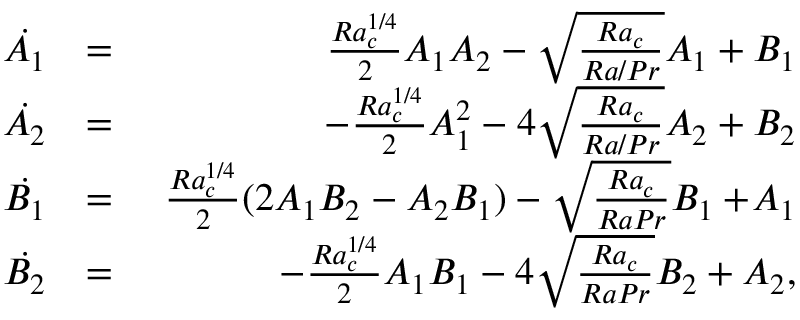<formula> <loc_0><loc_0><loc_500><loc_500>\begin{array} { r l r } { \, \dot { A _ { 1 } } } & { = } & { \ \frac { R a _ { c } ^ { 1 / 4 } } { 2 } A _ { 1 } A _ { 2 } - \sqrt { \frac { R a _ { c } } { R a / P r } } A _ { 1 } + B _ { 1 } } \\ { \, \dot { A _ { 2 } } } & { = } & { - \frac { R a _ { c } ^ { 1 / 4 } } { 2 } A _ { 1 } ^ { 2 } - 4 \sqrt { \frac { R a _ { c } } { R a / P r } } A _ { 2 } + B _ { 2 } } \\ { \, \dot { B _ { 1 } } } & { = } & { \ \frac { R a _ { c } ^ { 1 / 4 } } { 2 } ( 2 A _ { 1 } B _ { 2 } - A _ { 2 } B _ { 1 } ) - \sqrt { \frac { R a _ { c } } { R a P r } } B _ { 1 } + \, A _ { 1 } } \\ { \, \dot { B _ { 2 } } } & { = } & { - \frac { R a _ { c } ^ { 1 / 4 } } { 2 } A _ { 1 } B _ { 1 } - 4 \sqrt { \frac { R a _ { c } } { R a P r } } B _ { 2 } + A _ { 2 } , } \end{array}</formula> 